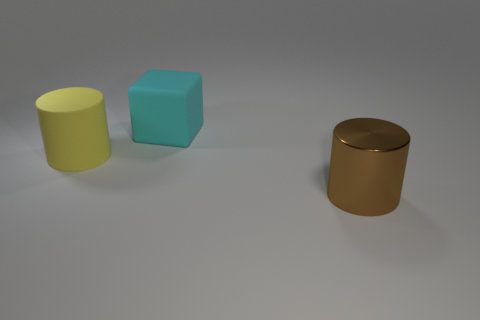Subtract all brown cylinders. Subtract all brown blocks. How many cylinders are left? 1 Add 2 tiny blue shiny objects. How many objects exist? 5 Subtract all cylinders. How many objects are left? 1 Add 2 large yellow matte cylinders. How many large yellow matte cylinders exist? 3 Subtract 0 purple cubes. How many objects are left? 3 Subtract all big metallic cylinders. Subtract all big cyan things. How many objects are left? 1 Add 3 matte cylinders. How many matte cylinders are left? 4 